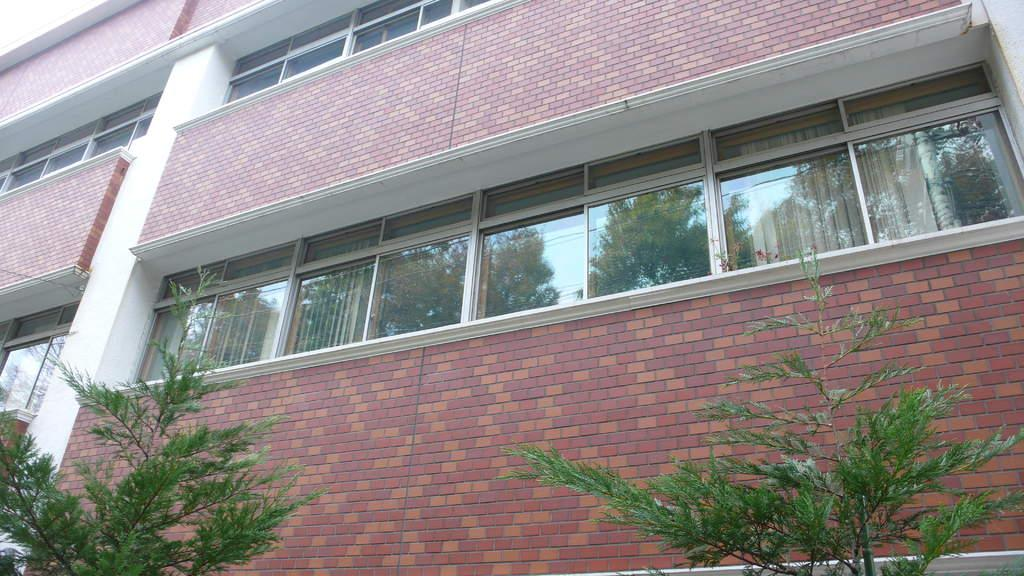What type of structure is visible in the image? There is a building in the image. What feature can be seen on the building? The building has windows. What type of vegetation is present at the bottom of the image? There are plants with leaves at the bottom of the image. What can be seen reflected on the windows of the building? There is a reflection of trees and buildings on the windows. What type of tail can be seen on the building in the image? There is no tail present on the building in the image. What is the creator of the bucket doing in the image? There is no bucket or creator mentioned in the image. 